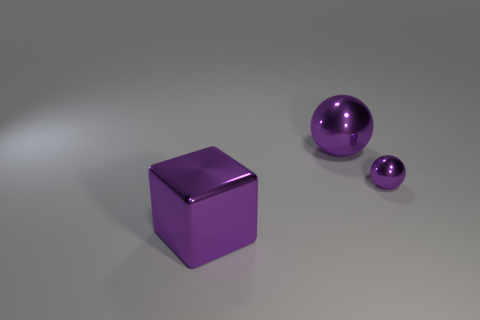Subtract all blocks. How many objects are left? 2 Subtract 1 balls. How many balls are left? 1 Add 1 big purple things. How many big purple things are left? 3 Add 2 small metallic objects. How many small metallic objects exist? 3 Add 3 large metal things. How many objects exist? 6 Subtract 0 brown balls. How many objects are left? 3 Subtract all green blocks. Subtract all yellow cylinders. How many blocks are left? 1 Subtract all tiny purple balls. Subtract all big purple metallic balls. How many objects are left? 1 